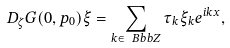<formula> <loc_0><loc_0><loc_500><loc_500>D _ { \zeta } G ( 0 , p _ { 0 } ) \xi = \sum _ { k \in \ B b b Z } \tau _ { k } \xi _ { k } e ^ { i k x } ,</formula> 